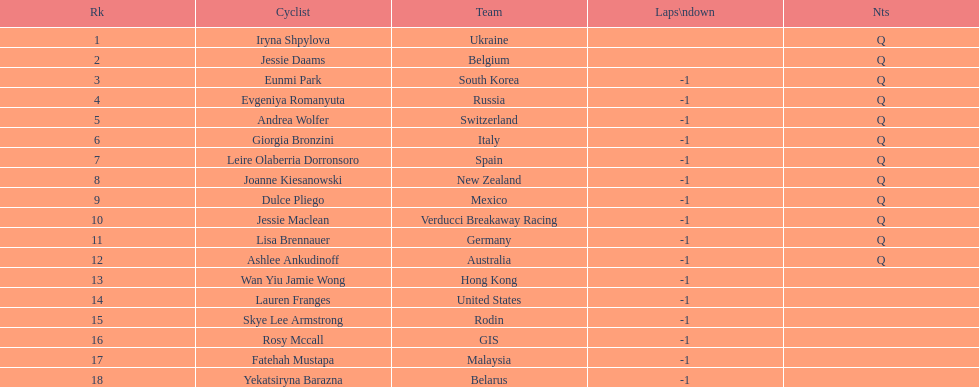Which team is mentioned before belgium? Ukraine. 